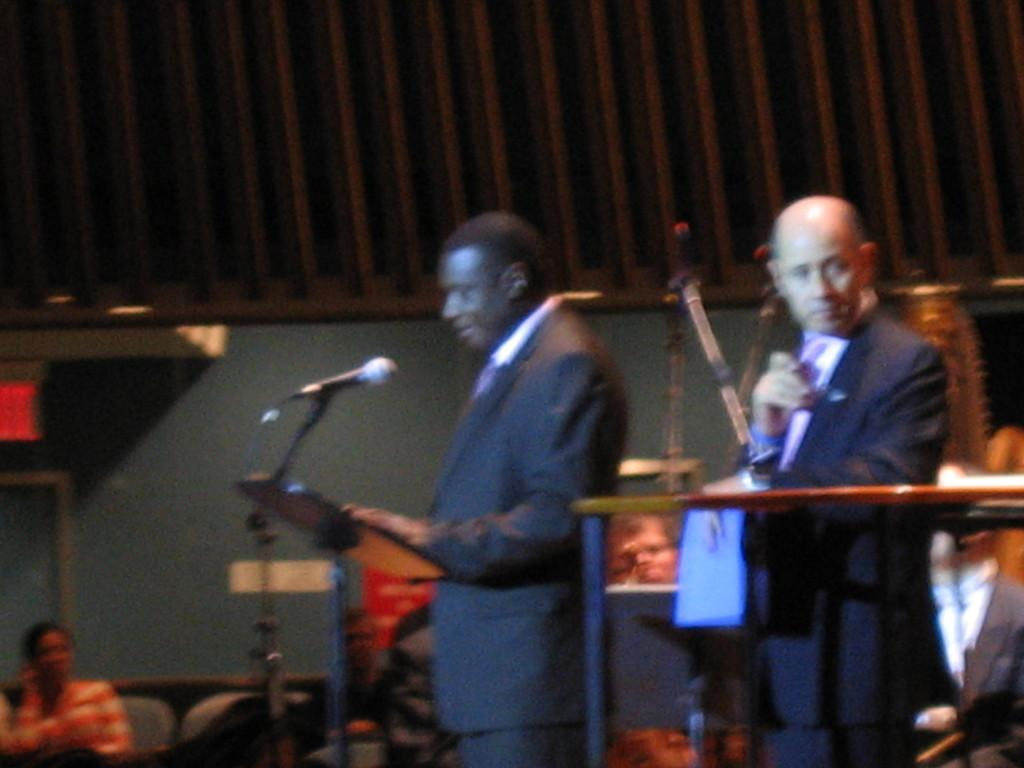How many people are in the image? There are two persons in the image. What are the persons wearing? Both persons are wearing suits. What are the persons doing in the image? The persons are standing. What object is in front of them? There is a microphone (mic) in front of them. Can you describe the person in the left corner of the image? There is another person in the left corner of the image. What type of market can be seen in the background of the image? There is no market visible in the image. What kind of apparatus is the person in the left corner using to play the guitar? There is no guitar or apparatus present in the image. 